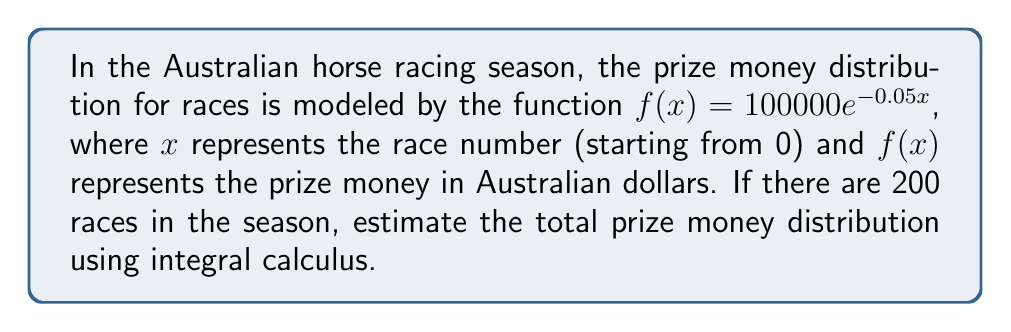Give your solution to this math problem. To estimate the total prize money distribution for the racing season, we need to calculate the definite integral of the given function over the interval [0, 200].

1. The function representing prize money distribution is:
   $f(x) = 100000e^{-0.05x}$

2. We need to calculate:
   $$\int_0^{200} 100000e^{-0.05x} dx$$

3. To solve this integral, we'll use the following antiderivative:
   $$\int e^{ax} dx = \frac{1}{a}e^{ax} + C$$

4. Applying this to our problem:
   $$\int 100000e^{-0.05x} dx = -2000000e^{-0.05x} + C$$

5. Now, we can calculate the definite integral:
   $$\begin{align}
   \int_0^{200} 100000e^{-0.05x} dx &= [-2000000e^{-0.05x}]_0^{200} \\
   &= -2000000e^{-0.05(200)} - (-2000000e^{-0.05(0)}) \\
   &= -2000000e^{-10} + 2000000
   \end{align}$$

6. Evaluating this expression:
   $$\begin{align}
   &= -2000000(0.0000453999) + 2000000 \\
   &= -90.7998 + 2000000 \\
   &= 1999909.2002
   \end{align}$$

Therefore, the estimated total prize money distribution for the racing season is approximately 1,999,909.20 Australian dollars.
Answer: $1,999,909.20 AUD 